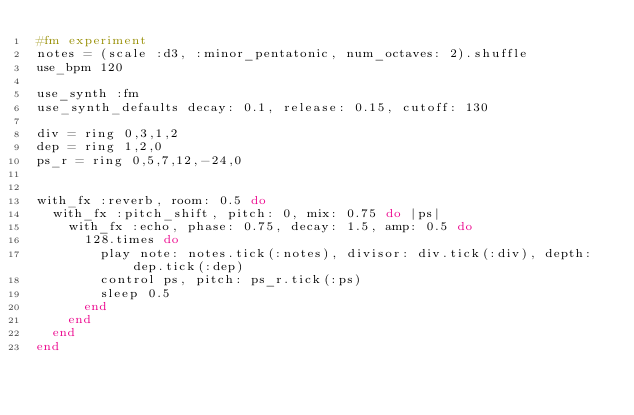Convert code to text. <code><loc_0><loc_0><loc_500><loc_500><_Ruby_>#fm experiment
notes = (scale :d3, :minor_pentatonic, num_octaves: 2).shuffle
use_bpm 120

use_synth :fm
use_synth_defaults decay: 0.1, release: 0.15, cutoff: 130

div = ring 0,3,1,2
dep = ring 1,2,0
ps_r = ring 0,5,7,12,-24,0


with_fx :reverb, room: 0.5 do
  with_fx :pitch_shift, pitch: 0, mix: 0.75 do |ps|
    with_fx :echo, phase: 0.75, decay: 1.5, amp: 0.5 do
      128.times do
        play note: notes.tick(:notes), divisor: div.tick(:div), depth: dep.tick(:dep)
        control ps, pitch: ps_r.tick(:ps)
        sleep 0.5
      end
    end
  end
end</code> 